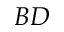<formula> <loc_0><loc_0><loc_500><loc_500>B D</formula> 